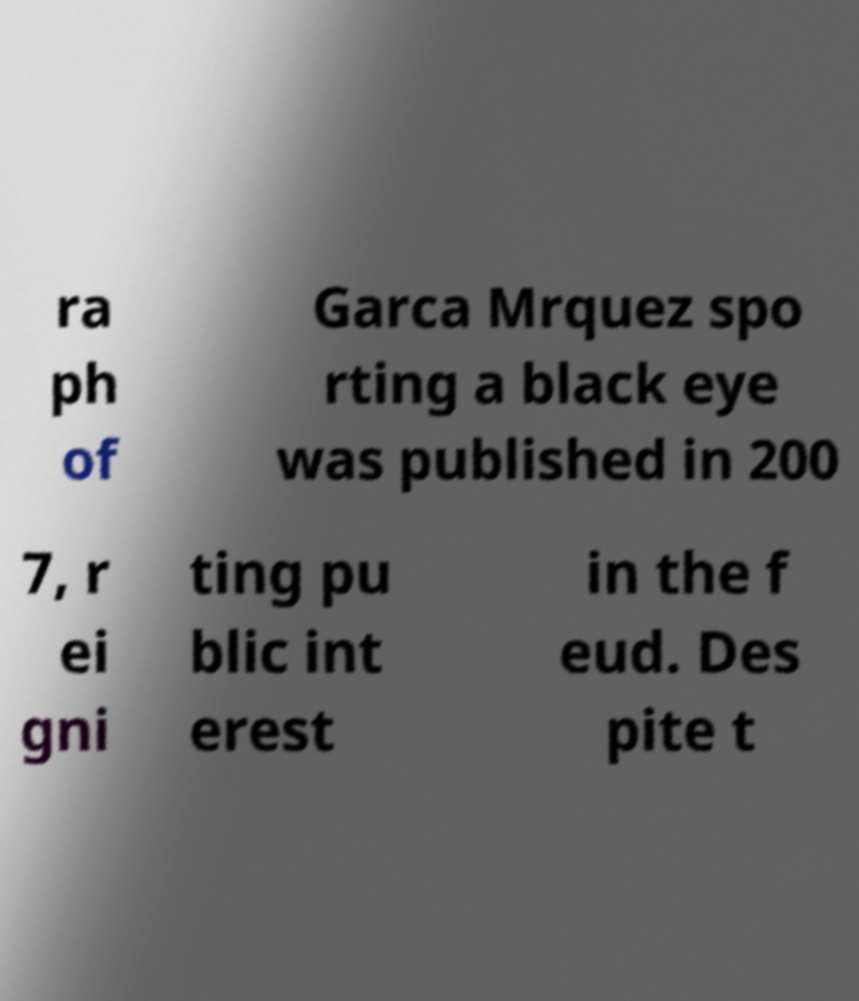Please read and relay the text visible in this image. What does it say? ra ph of Garca Mrquez spo rting a black eye was published in 200 7, r ei gni ting pu blic int erest in the f eud. Des pite t 